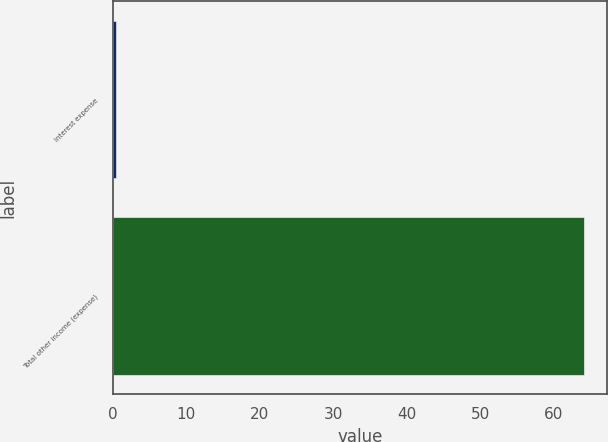Convert chart to OTSL. <chart><loc_0><loc_0><loc_500><loc_500><bar_chart><fcel>Interest expense<fcel>Total other income (expense)<nl><fcel>0.5<fcel>64.1<nl></chart> 